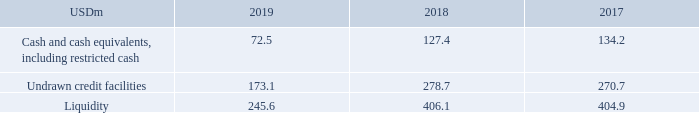ALTERNATIVE PERFORMANCE MEASURES – continued
Liquidity: TORM defines liquidity as available cash, comprising cash and cash equivalents, including restricted cash, as well as undrawn credit facilities.
TORM finds the APM important as the liquidity expresses TORM’s financial position, ability to meet current liabilities and cash buffer. Furthermore, it expresses TORM’s ability to act and invest when possibilities occur.
How does TORM define liquidity? Torm defines liquidity as available cash, comprising cash and cash equivalents, including restricted cash, as well as undrawn credit facilities. Why does TORM find the APM important? As the liquidity expresses torm’s financial position, ability to meet current liabilities and cash buffer. furthermore, it expresses torm’s ability to act and invest when possibilities occur. What are the components in the table used to calculate liquidity? Cash and cash equivalents, including restricted cash, undrawn credit facilities. In which year was liquidity the largest? 406.1>404.9>245.6
Answer: 2018. What was the change in liquidity in 2019 from 2018?
Answer scale should be: million. 245.6-406.1
Answer: -160.5. What was the percentage change in liquidity in 2019 from 2018?
Answer scale should be: percent. (245.6-406.1)/406.1
Answer: -39.52. 